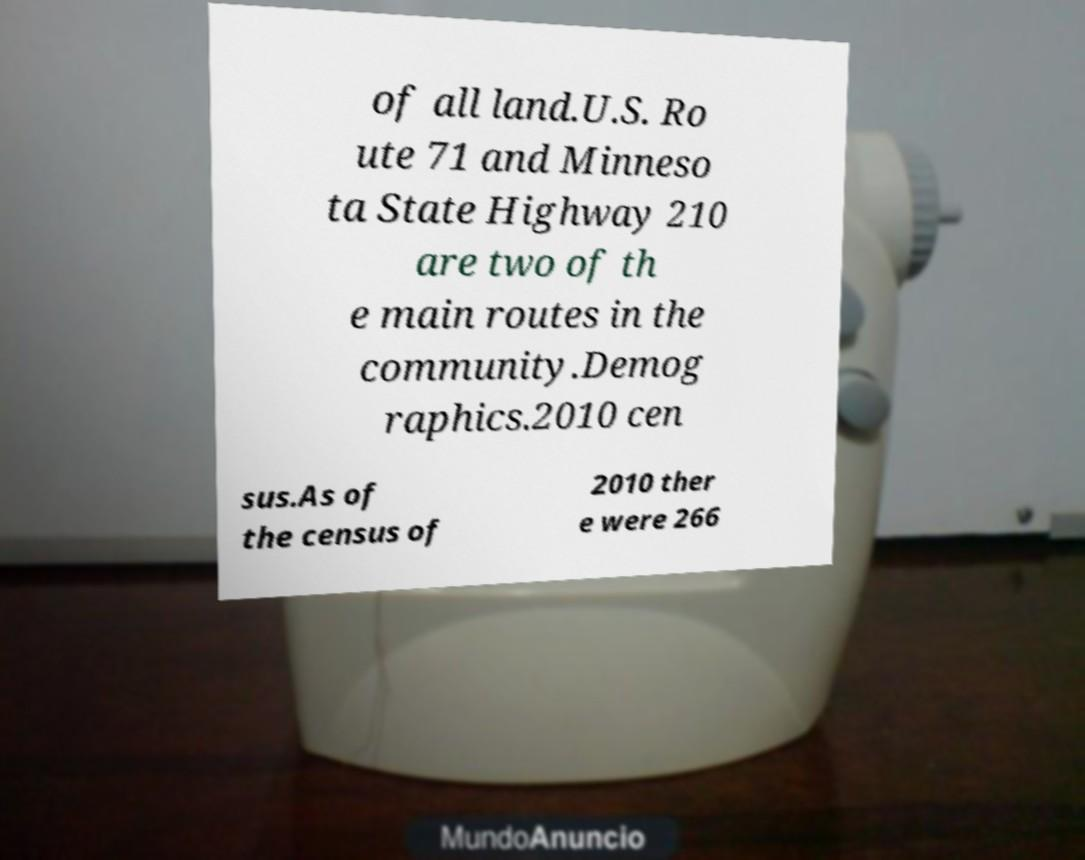What messages or text are displayed in this image? I need them in a readable, typed format. of all land.U.S. Ro ute 71 and Minneso ta State Highway 210 are two of th e main routes in the community.Demog raphics.2010 cen sus.As of the census of 2010 ther e were 266 